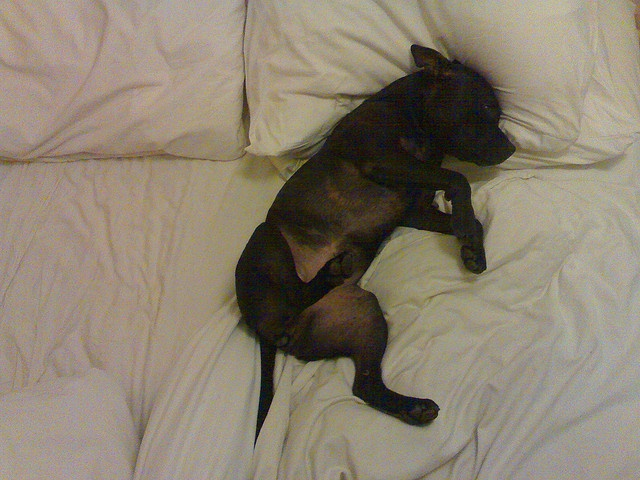Describe the objects in this image and their specific colors. I can see bed in darkgray, tan, and gray tones and dog in darkgray, black, maroon, olive, and navy tones in this image. 